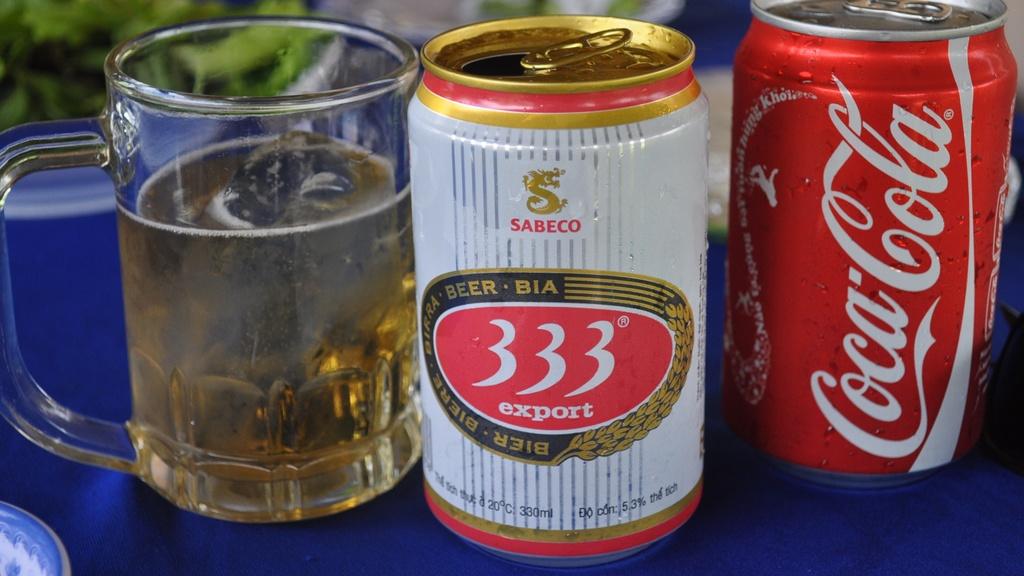The red can is what brand?
Your response must be concise. Coca cola. What brand is the beer?
Offer a very short reply. Sabeco. 